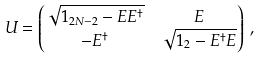<formula> <loc_0><loc_0><loc_500><loc_500>U & = \begin{pmatrix} \sqrt { 1 _ { 2 N - 2 } - E E ^ { \dag } } & E \\ - E ^ { \dag } & \sqrt { 1 _ { 2 } - E ^ { \dag } E } \end{pmatrix} \ ,</formula> 